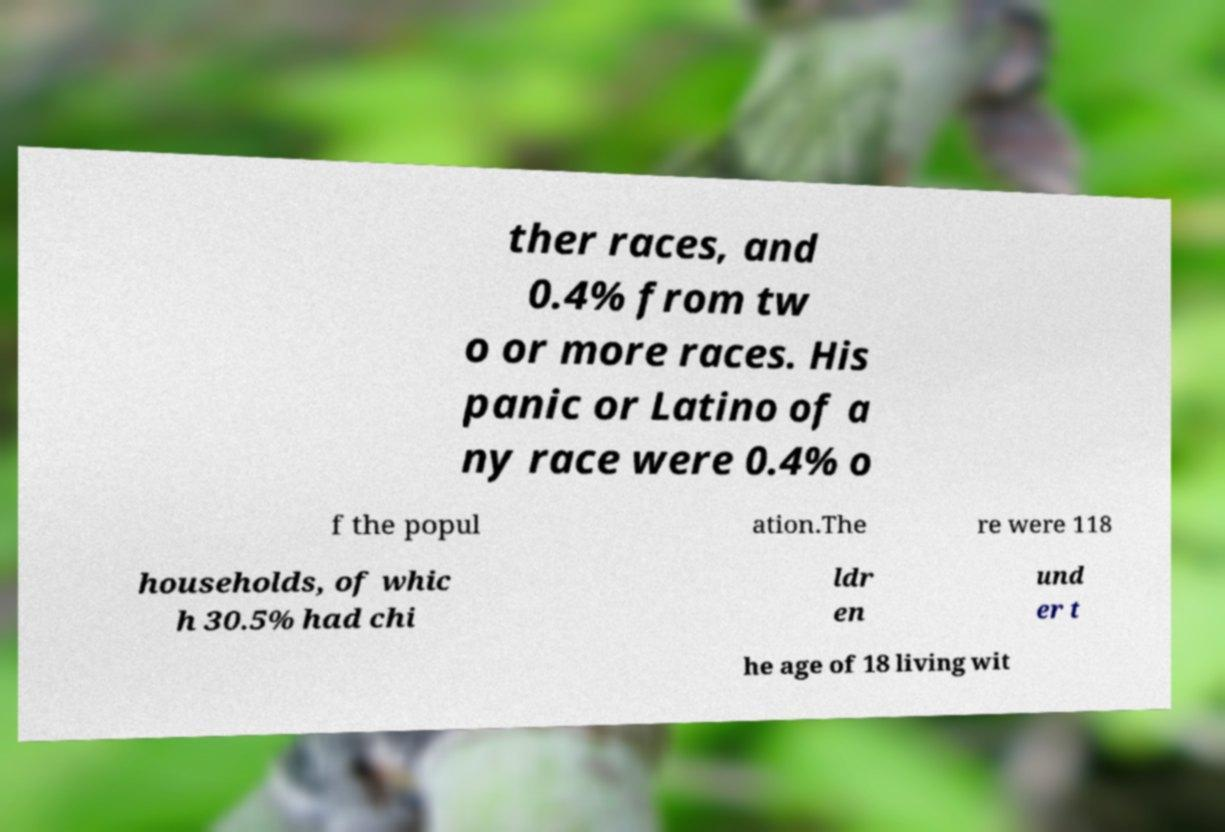Could you assist in decoding the text presented in this image and type it out clearly? ther races, and 0.4% from tw o or more races. His panic or Latino of a ny race were 0.4% o f the popul ation.The re were 118 households, of whic h 30.5% had chi ldr en und er t he age of 18 living wit 